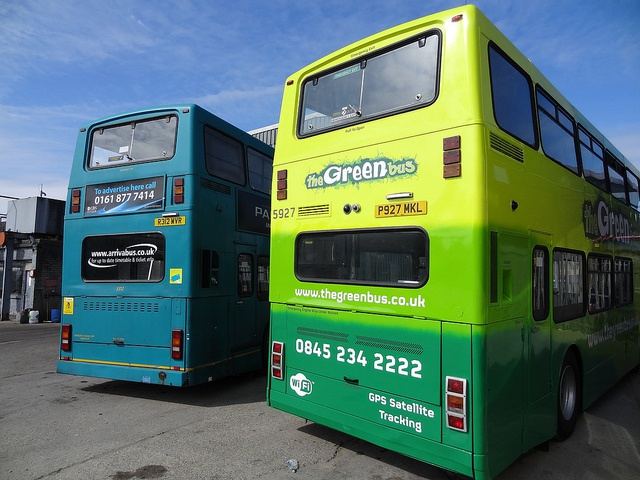Describe the objects in this image and their specific colors. I can see bus in gray, black, yellow, green, and darkgreen tones and bus in gray, black, and teal tones in this image. 